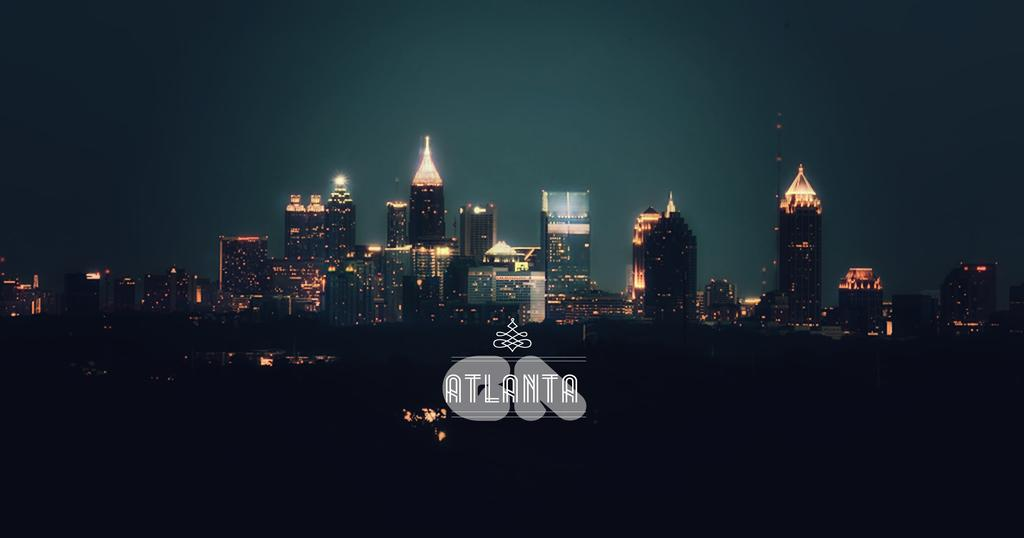Provide a one-sentence caption for the provided image. The skyline of Atlanta is lit up at night. 